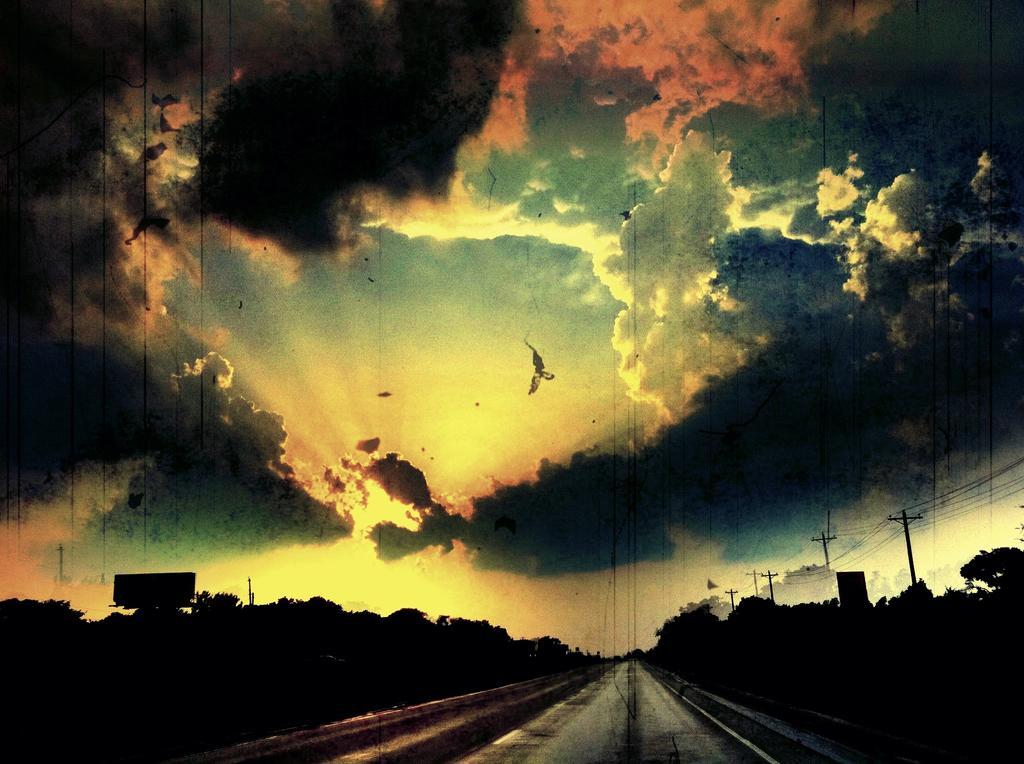Could you give a brief overview of what you see in this image? At the bottom of the picture we can see trees, current poles, cables, road and other objects. At the top it is sky. 